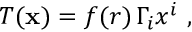<formula> <loc_0><loc_0><loc_500><loc_500>T ( { x } ) = f ( r ) \, \Gamma _ { i } x ^ { i } ,</formula> 